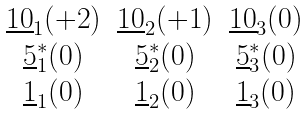Convert formula to latex. <formula><loc_0><loc_0><loc_500><loc_500>\begin{array} { c c c } \underline { 1 0 } _ { 1 } ( { + 2 } ) & \underline { 1 0 } _ { 2 } ( { + 1 } ) & \underline { 1 0 } _ { 3 } ( { 0 } ) \\ \underline { 5 } ^ { * } _ { 1 } ( { 0 } ) & \underline { 5 } ^ { * } _ { 2 } ( { 0 } ) & \underline { 5 } ^ { * } _ { 3 } ( { 0 } ) \\ \underline { 1 } _ { 1 } ( { 0 } ) & \underline { 1 } _ { 2 } ( { 0 } ) & \underline { 1 } _ { 3 } ( { 0 } ) \end{array}</formula> 